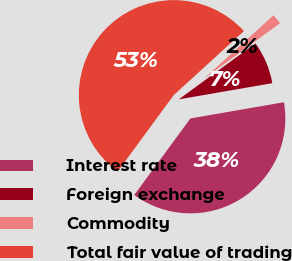<chart> <loc_0><loc_0><loc_500><loc_500><pie_chart><fcel>Interest rate<fcel>Foreign exchange<fcel>Commodity<fcel>Total fair value of trading<nl><fcel>37.8%<fcel>7.31%<fcel>1.73%<fcel>53.16%<nl></chart> 